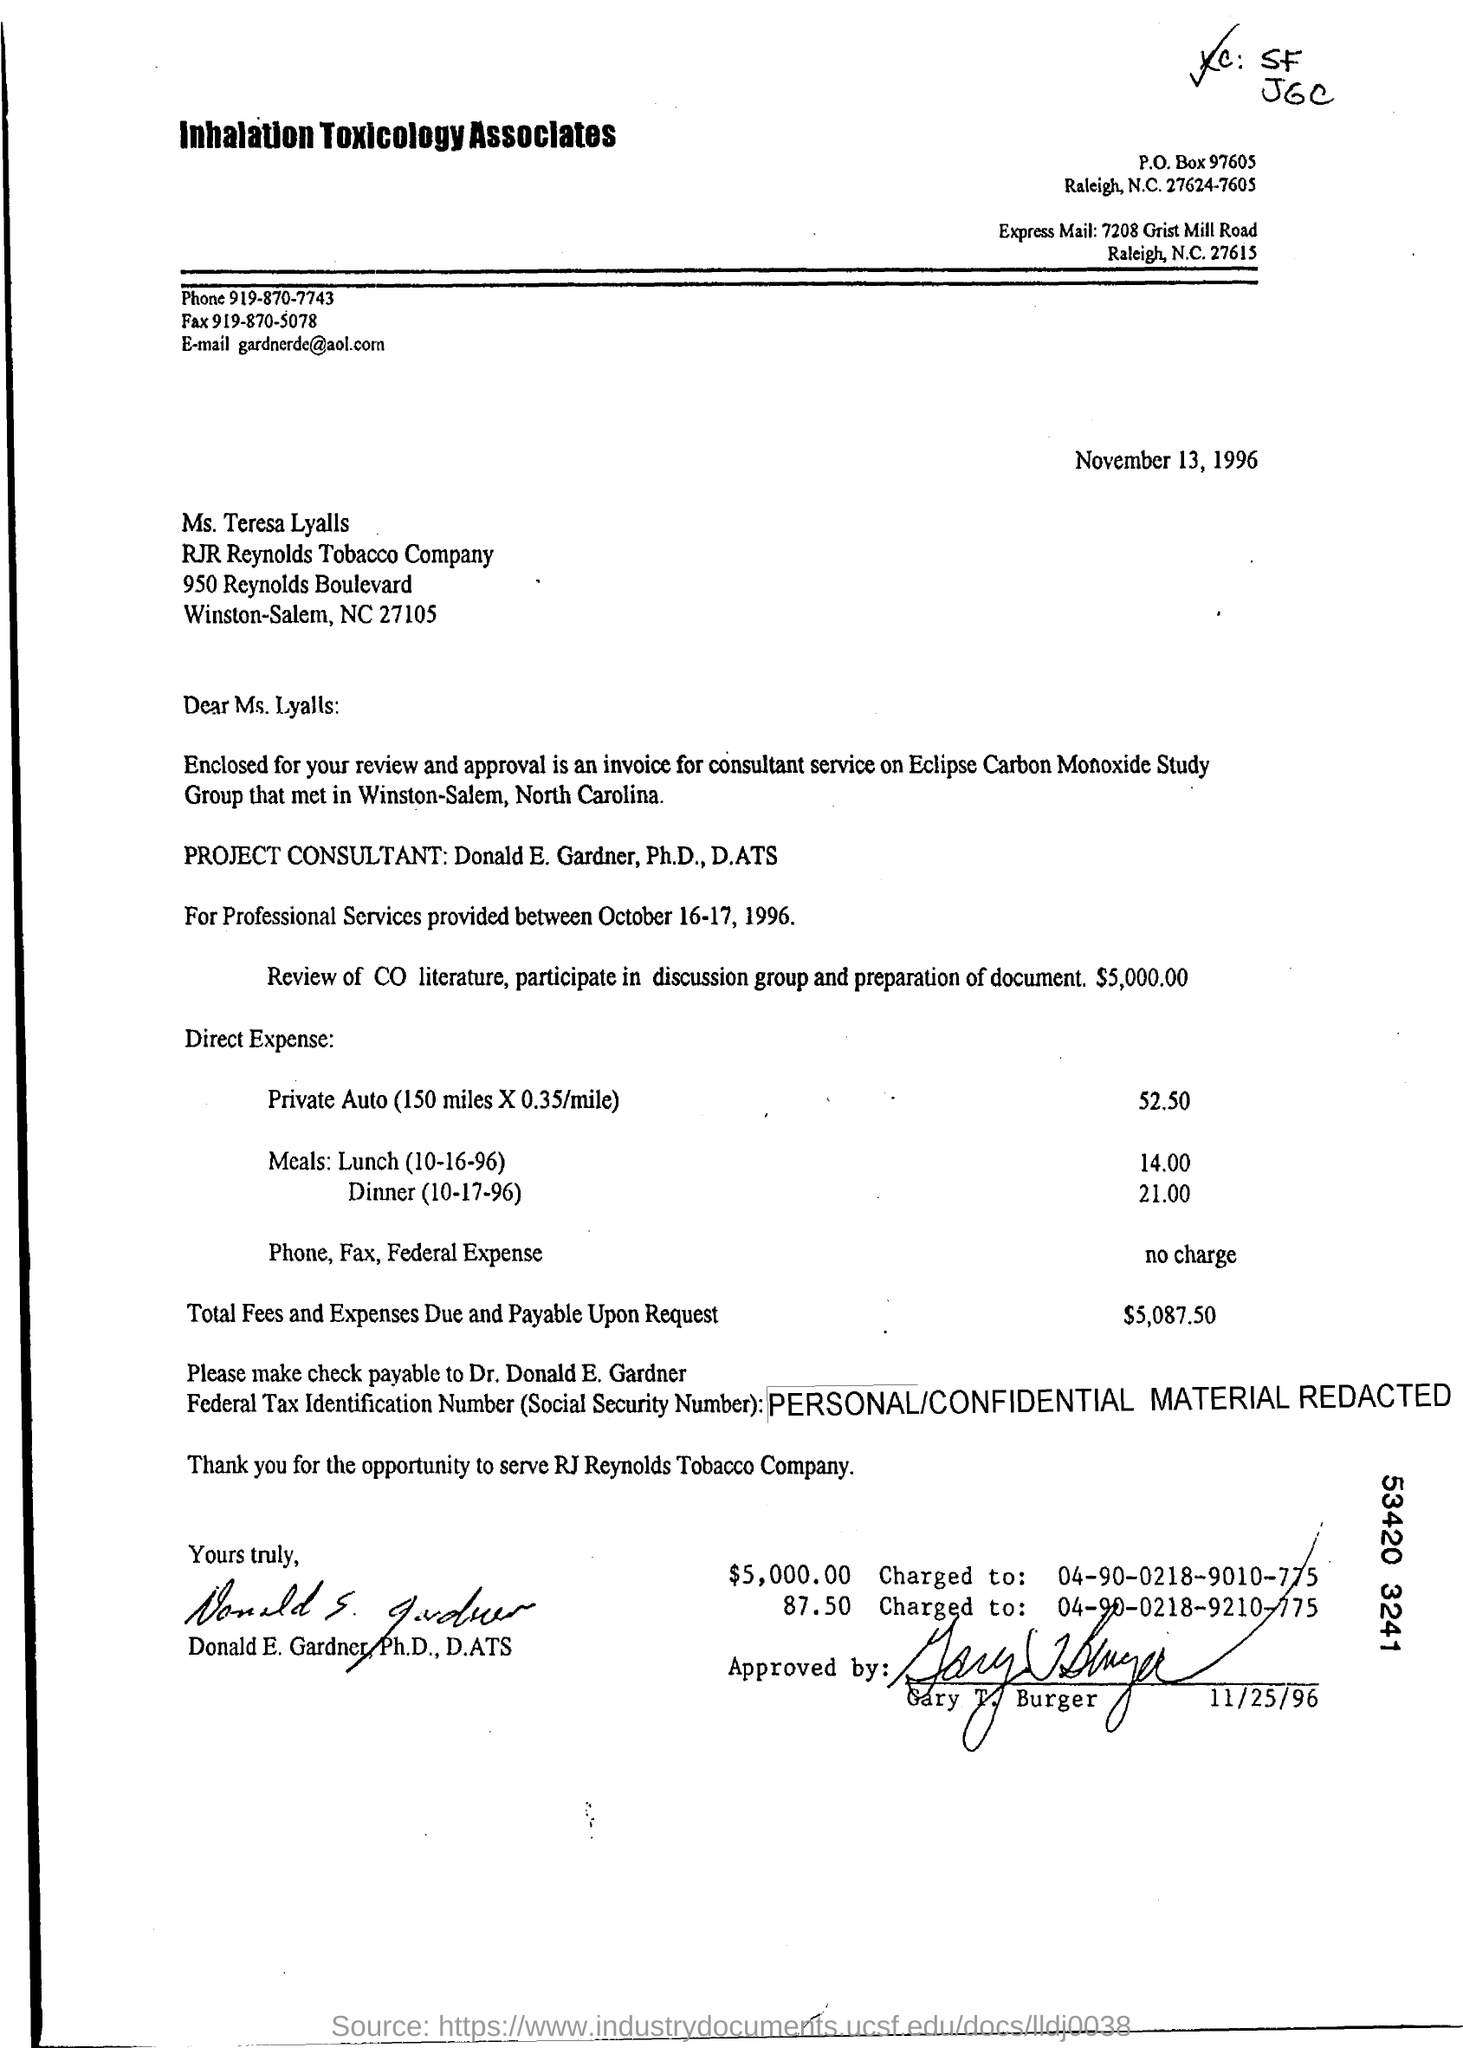Point out several critical features in this image. The phone number is 919-870-7743. The fax number is 919-870-5078. 